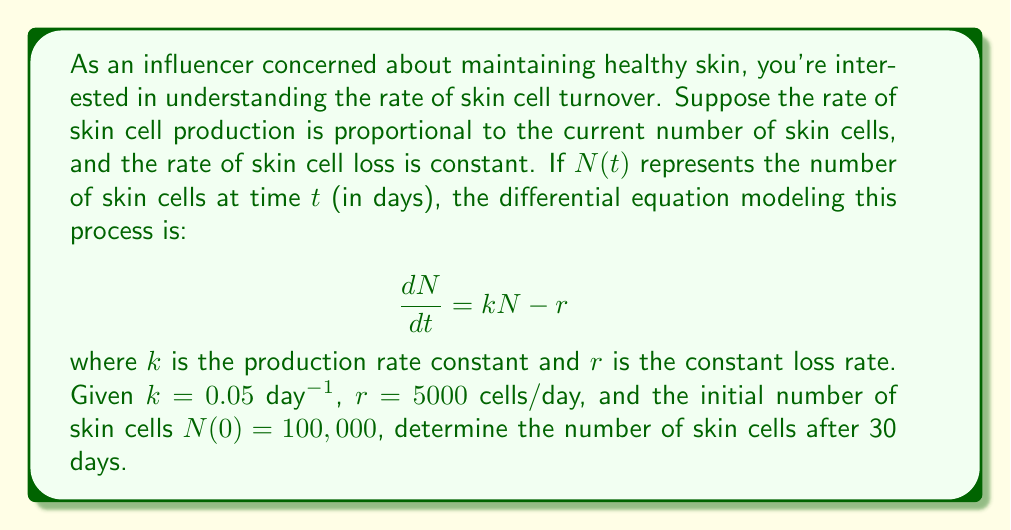Could you help me with this problem? To solve this problem, we need to follow these steps:

1) First, we need to solve the differential equation:
   $$\frac{dN}{dt} = kN - r$$

2) This is a first-order linear differential equation. The general solution is:
   $$N(t) = \frac{r}{k} + Ce^{kt}$$
   where $C$ is a constant determined by the initial condition.

3) Using the initial condition $N(0) = 100,000$, we can find $C$:
   $$100,000 = \frac{5000}{0.05} + C$$
   $$C = 100,000 - 100,000 = 0$$

4) Therefore, the particular solution is:
   $$N(t) = \frac{r}{k} = \frac{5000}{0.05} = 100,000$$

5) This means that the number of skin cells remains constant at 100,000 over time. This is because the production rate exactly balances the loss rate.

6) After 30 days, the number of skin cells will still be 100,000.

This result suggests that under these conditions, your skin cell population remains in a steady state, which is ideal for maintaining consistent skin health and appearance.
Answer: The number of skin cells after 30 days: 100,000 cells 